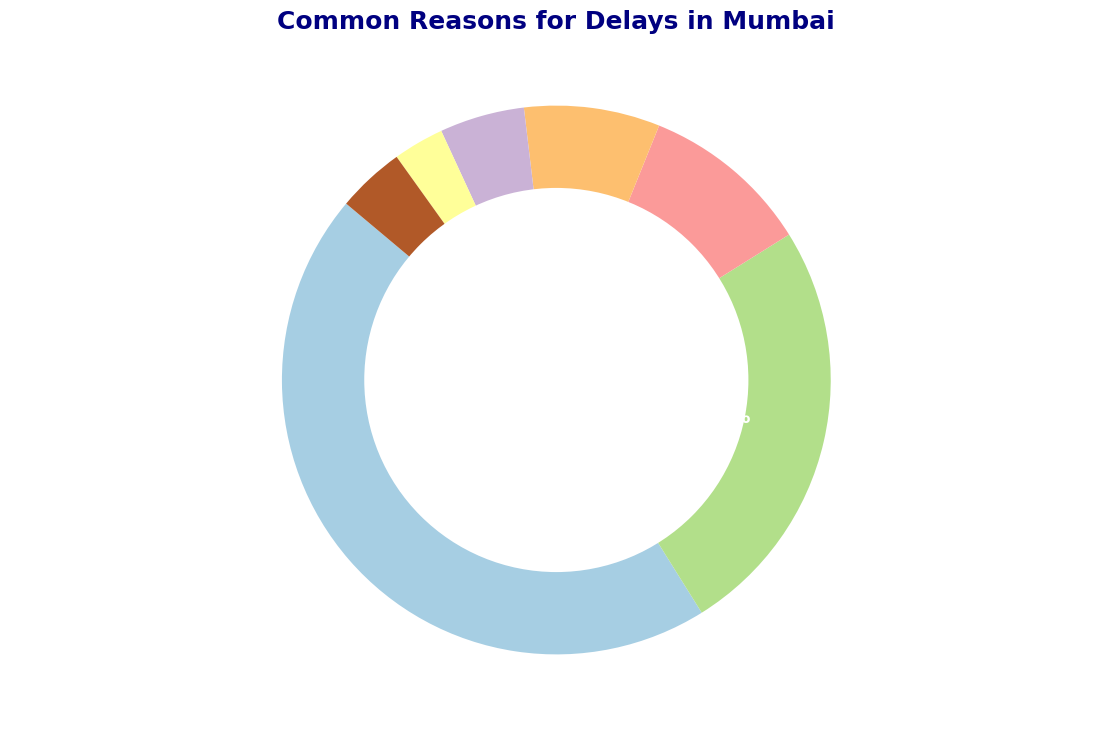What is the most common reason for delays in Mumbai? The pie chart shows the percentage distribution of different reasons for delays. The largest segment represents Traffic Congestion at 45%.
Answer: Traffic Congestion Which two reasons together cause the most delays, and what is their combined percentage? Adding the percentages of the two largest factors, Traffic Congestion (45%) and Public Transport Delays (25%), gives a combined percentage.
Answer: Traffic Congestion and Public Transport Delays, 70% What is the least common reason for delays in Mumbai? By comparing all the segments, the smallest segment is for Electronic Commuter System Issues at 3%.
Answer: Electronic Commuter System Issues How does the percentage of delays due to weather conditions compare to those due to personal delays? Weather Conditions account for 10%, while Personal Delays account for 4%. 10% is greater than 4%.
Answer: Weather Conditions is greater By how much does construction work contribute more to delays than personal delays? Subtract the percentage of Personal Delays (4%) from Construction Work (8%).
Answer: 4% What is the total percentage of delays caused by Construction Work, Strikes and Protests, and Electronic Commuter System Issues combined? Adding the percentages: Construction Work (8%) + Strikes and Protests (5%) + Electronic Commuter System Issues (3%) = 16%.
Answer: 16% What percentage more do Public Transport Delays contribute to delays compared to Weather Conditions? Subtract Weather Conditions (10%) from Public Transport Delays (25%).
Answer: 15% What are the visual colors used to represent Traffic Congestion and Public Transport Delays in the chart? The pie chart uses a color palette, and the corresponding segment for Traffic Congestion and Public Transport Delays can be identified by their place in the legend or directly from the chart.
Answer: Varies based on palette If the Electronic Commuter System Issues and Personal Delays were combined into one category, what would be the new percentage for this combined category? Adding the percentages: Electronic Commuter System Issues (3%) + Personal Delays (4%), the new category would be 7%.
Answer: 7% Which category has a percentage closest to the average percentage of all the given reasons? First, calculate the average percentage: (45 + 25 + 10 + 8 + 5 + 3 + 4) / 7 = 100 / 7 ≈ 14.3%. Then, identify the category closest to this average.
Answer: Strikes and Protests (5%) 